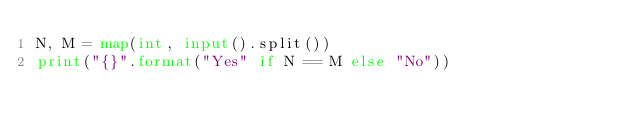<code> <loc_0><loc_0><loc_500><loc_500><_Python_>N, M = map(int, input().split())
print("{}".format("Yes" if N == M else "No"))</code> 